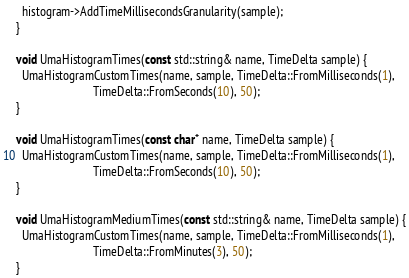<code> <loc_0><loc_0><loc_500><loc_500><_C++_>  histogram->AddTimeMillisecondsGranularity(sample);
}

void UmaHistogramTimes(const std::string& name, TimeDelta sample) {
  UmaHistogramCustomTimes(name, sample, TimeDelta::FromMilliseconds(1),
                          TimeDelta::FromSeconds(10), 50);
}

void UmaHistogramTimes(const char* name, TimeDelta sample) {
  UmaHistogramCustomTimes(name, sample, TimeDelta::FromMilliseconds(1),
                          TimeDelta::FromSeconds(10), 50);
}

void UmaHistogramMediumTimes(const std::string& name, TimeDelta sample) {
  UmaHistogramCustomTimes(name, sample, TimeDelta::FromMilliseconds(1),
                          TimeDelta::FromMinutes(3), 50);
}
</code> 